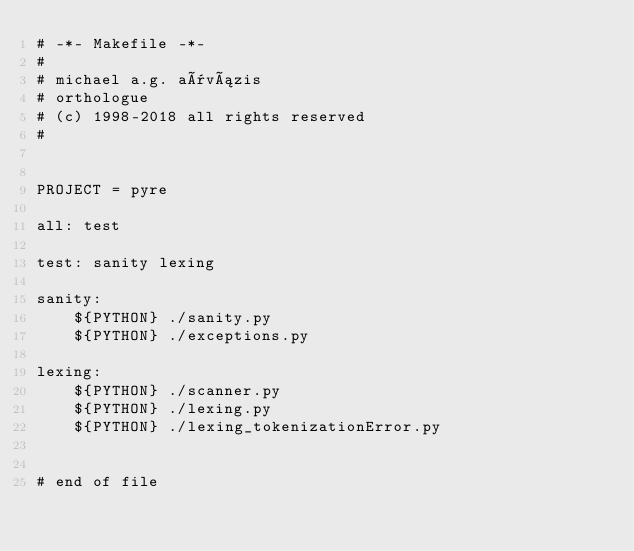<code> <loc_0><loc_0><loc_500><loc_500><_ObjectiveC_># -*- Makefile -*-
#
# michael a.g. aïvázis
# orthologue
# (c) 1998-2018 all rights reserved
#


PROJECT = pyre

all: test

test: sanity lexing

sanity:
	${PYTHON} ./sanity.py
	${PYTHON} ./exceptions.py

lexing:
	${PYTHON} ./scanner.py
	${PYTHON} ./lexing.py
	${PYTHON} ./lexing_tokenizationError.py


# end of file
</code> 